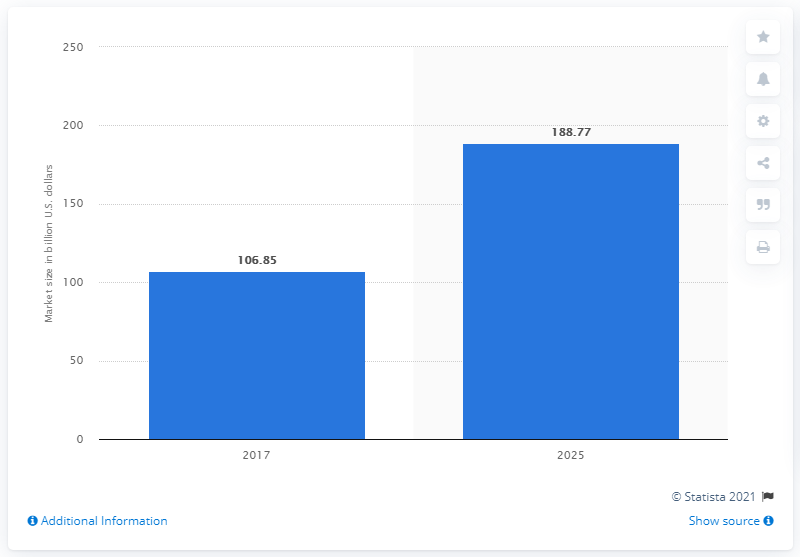Indicate a few pertinent items in this graphic. The market for mining equipment is expected to reach a value of US dollars by 2025, with a predicted growth rate of 188.77%. 